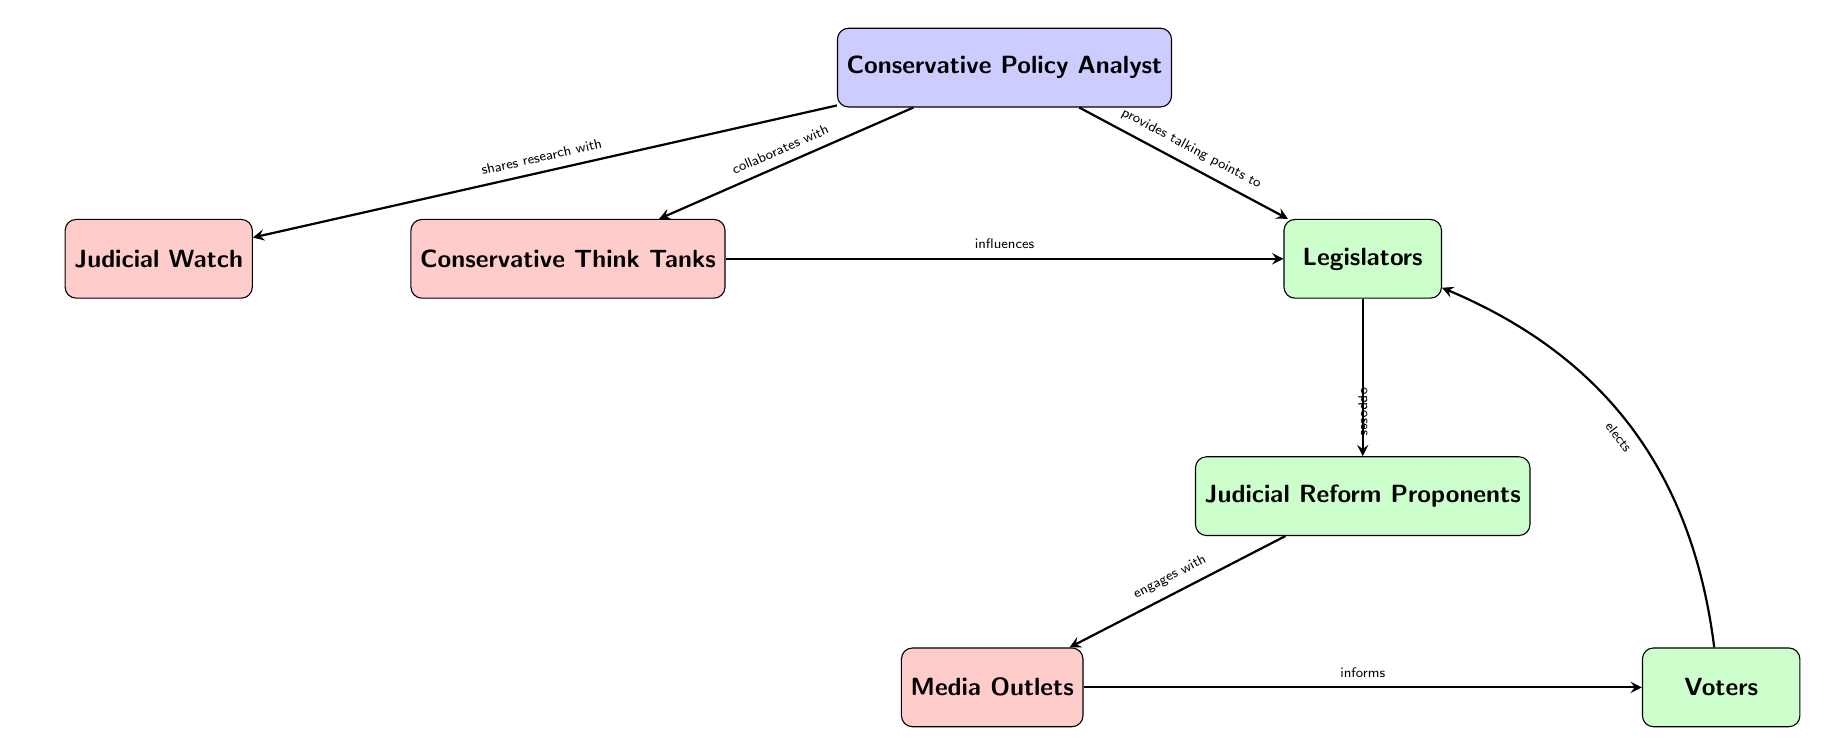What is the total number of entities in the diagram? There are 7 entities listed in the diagram, which include "Conservative Policy Analyst", "Judicial Reform Proponents", "Conservative Think Tanks", "Legislators", "Judicial Watch", "Media Outlets", and "Voters".
Answer: 7 Who does the Conservative Policy Analyst provide talking points to? According to the diagram, the Conservative Policy Analyst provides talking points specifically to the Legislators. This relationship is represented with the "provides talking points to" arrow.
Answer: Legislators Which organization is connected to Judicial Watch? In the diagram, the Conservative Policy Analyst shares research with Judicial Watch, representing a connection between them.
Answer: Conservative Policy Analyst How many relationships are outgoing from the Legislators? The Legislators have 2 outgoing relationships in the diagram; they oppose Judicial Reform Proponents and are influenced by Conservative Think Tanks. This shows their role in influencing and being influenced.
Answer: 2 What type of relationship exists between Judicial Reform Proponents and Media Outlets? The relationship between Judicial Reform Proponents and Media Outlets is characterized by "engages with". This indicates how the proponents interact with the media.
Answer: engages with What is the relationship type that connects Media Outlets to Voters? The diagram states that Media Outlets "informs" Voters. This implies that there is a direct flow of information from the media to the voters.
Answer: informs Who influences the Legislators according to the diagram? The Conservative Think Tanks are specifically noted to influence the Legislators in the diagram, indicating that they have a role in shaping legislative opinions or actions.
Answer: Conservative Think Tanks What do Voters do to Legislators? The relationship indicated in the diagram is that Voters "elect" Legislators, showcasing a direct participatory action in governance.
Answer: elects Which group does Legislators oppose? According to the diagram, the Legislators oppose the Judicial Reform Proponents, reflecting a direct conflict or opposition.
Answer: Judicial Reform Proponents 